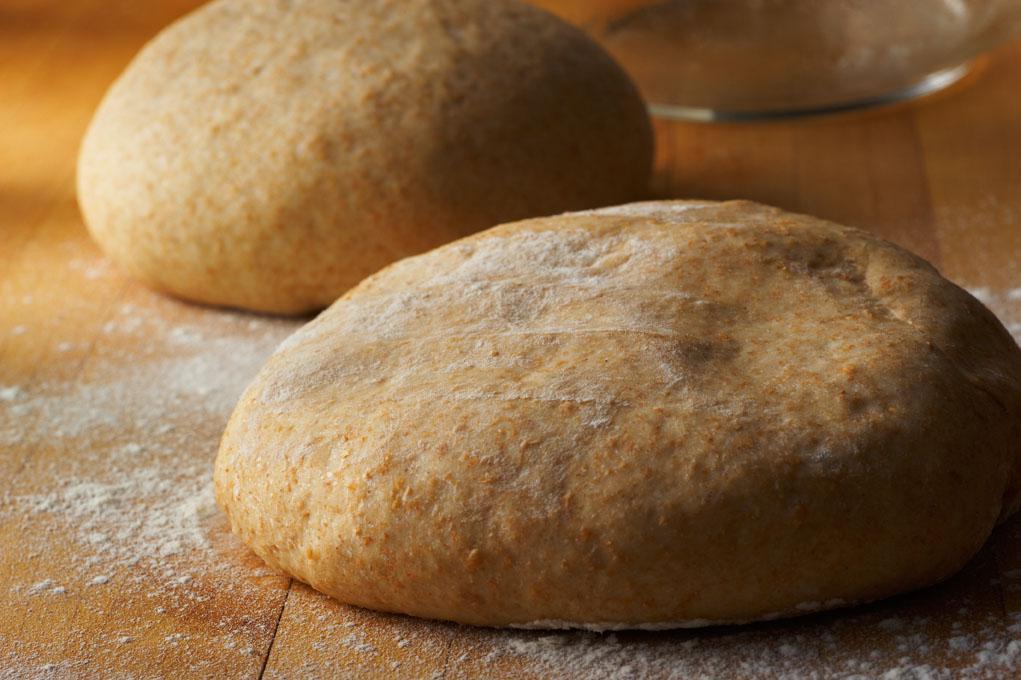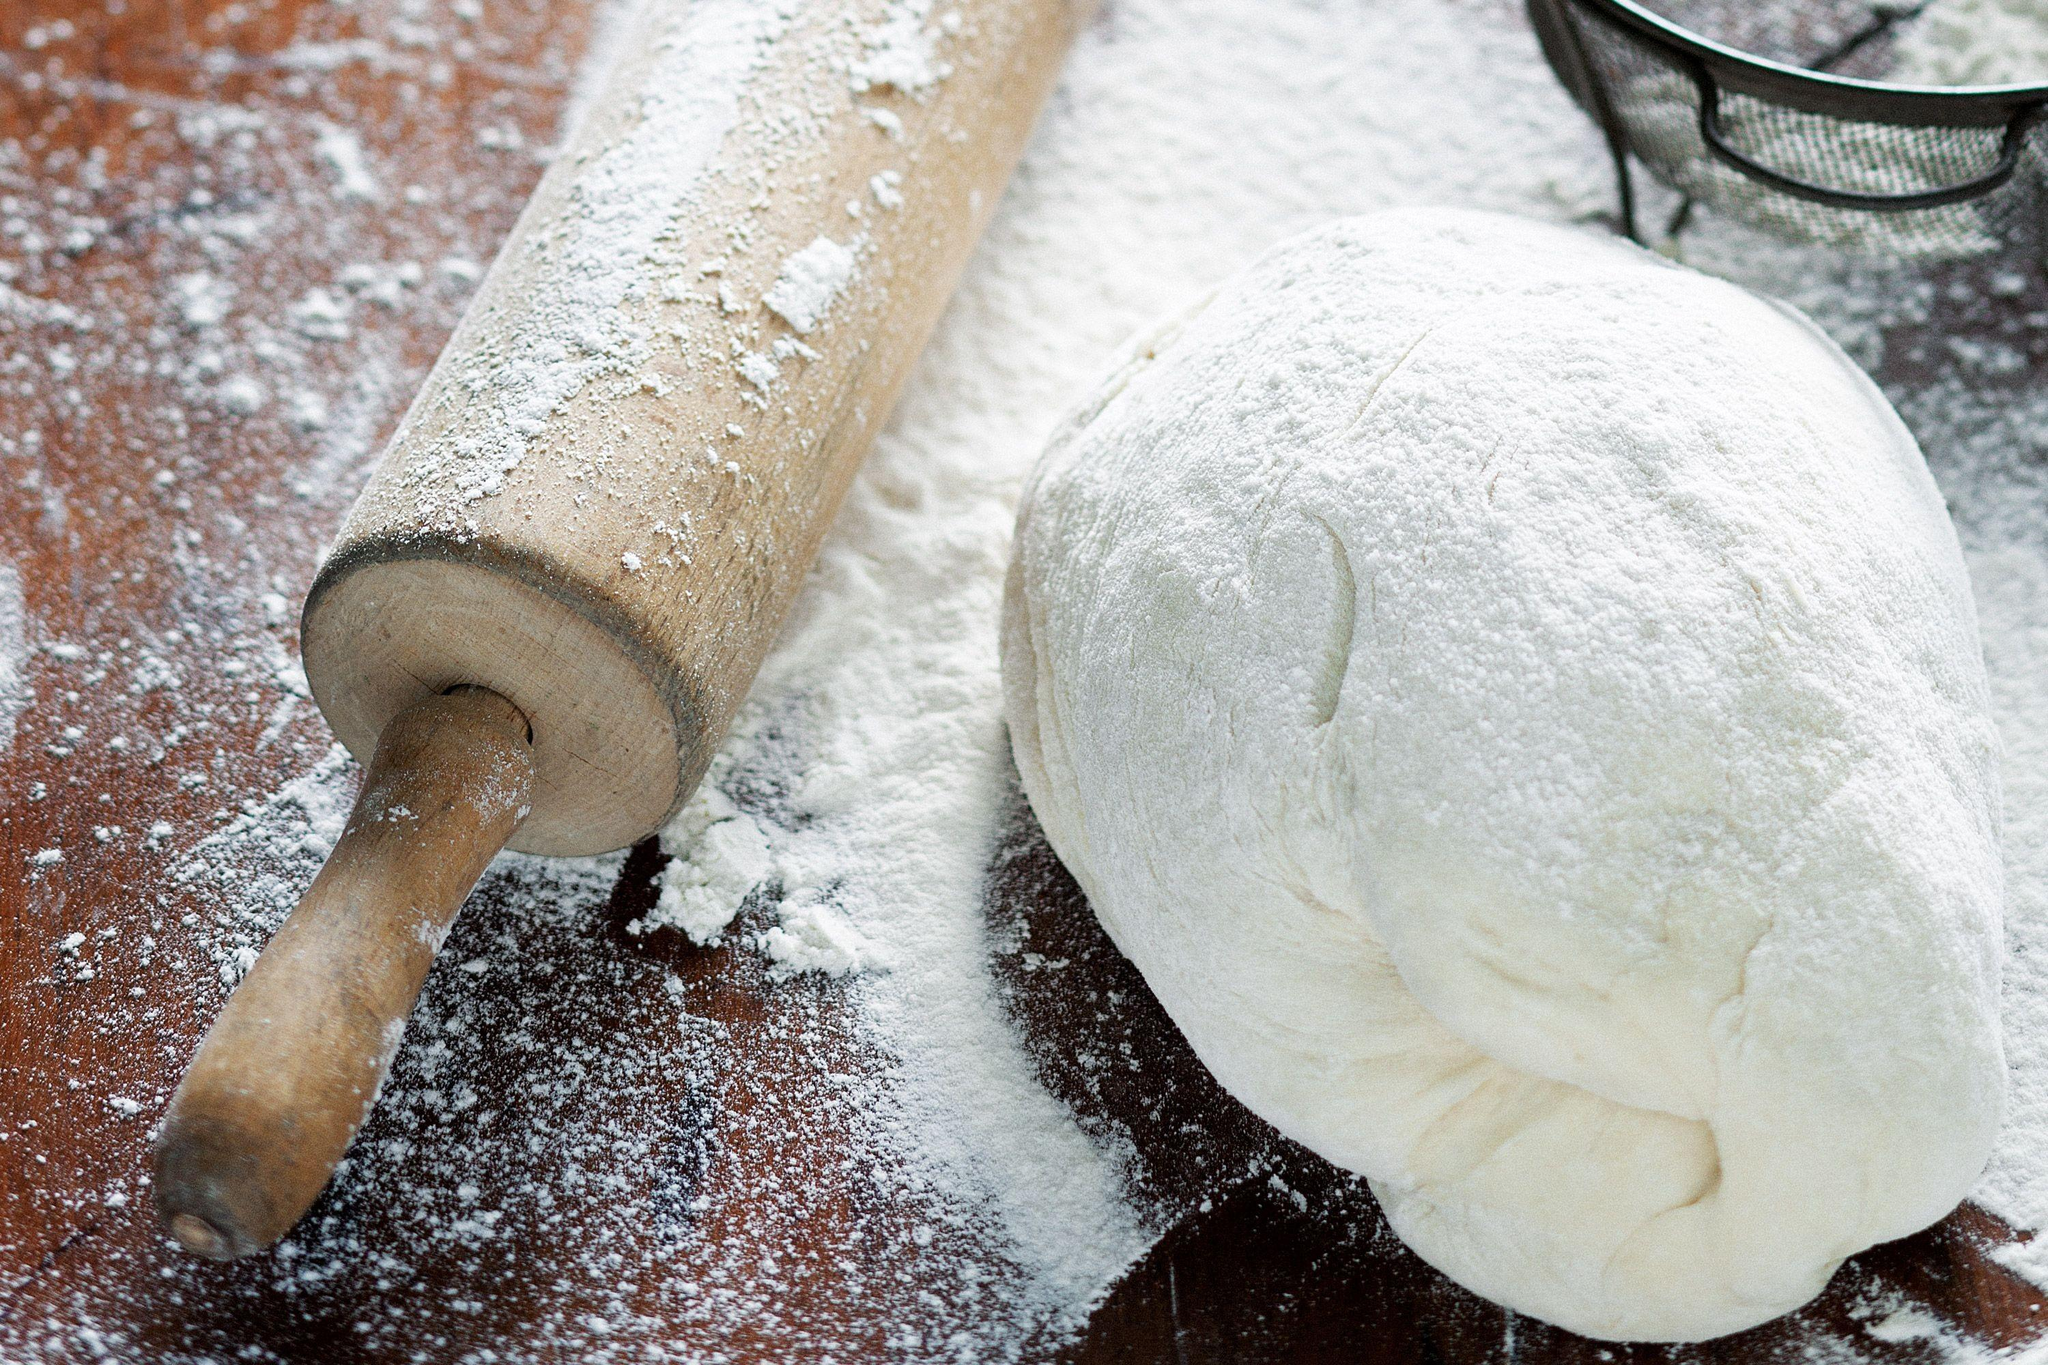The first image is the image on the left, the second image is the image on the right. Considering the images on both sides, is "Each image contains exactly one rounded pale-colored raw dough ball, and one of the images features a dough ball on a wood surface dusted with flour." valid? Answer yes or no. No. 